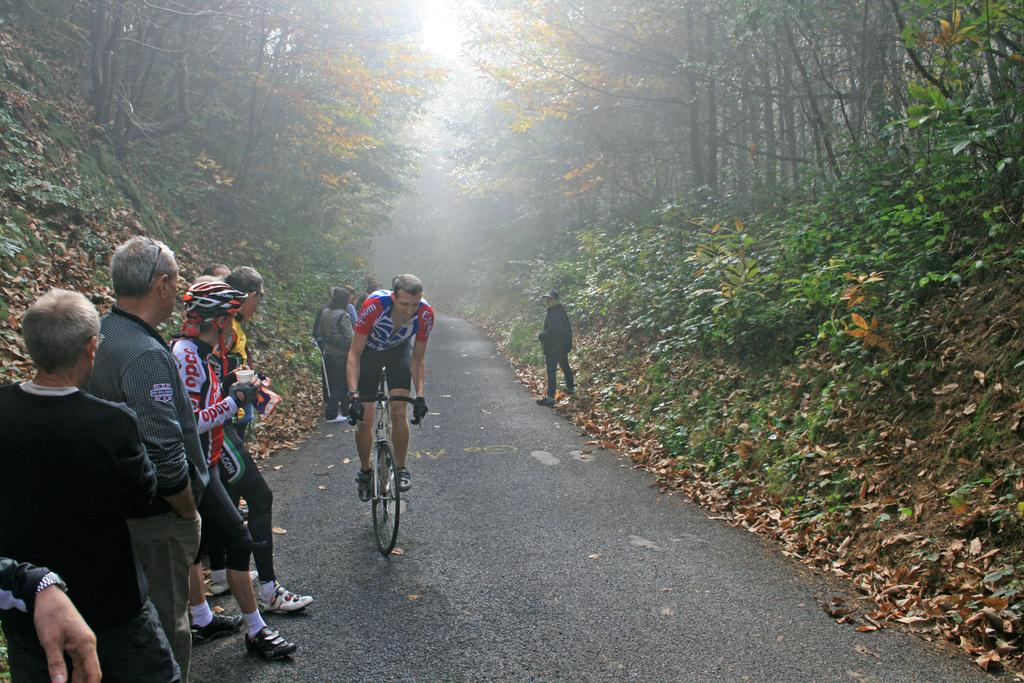How many people are in the image? There are persons standing in the image. What activity is one person engaged in? There is a person riding a bicycle in the image. What type of natural environment can be seen in the background? There are trees visible in the background of the image. What type of pathway is present in the image? The image contains a road. Can you see a duck swinging on a tree branch in the image? There is no duck or swing present in the image. 